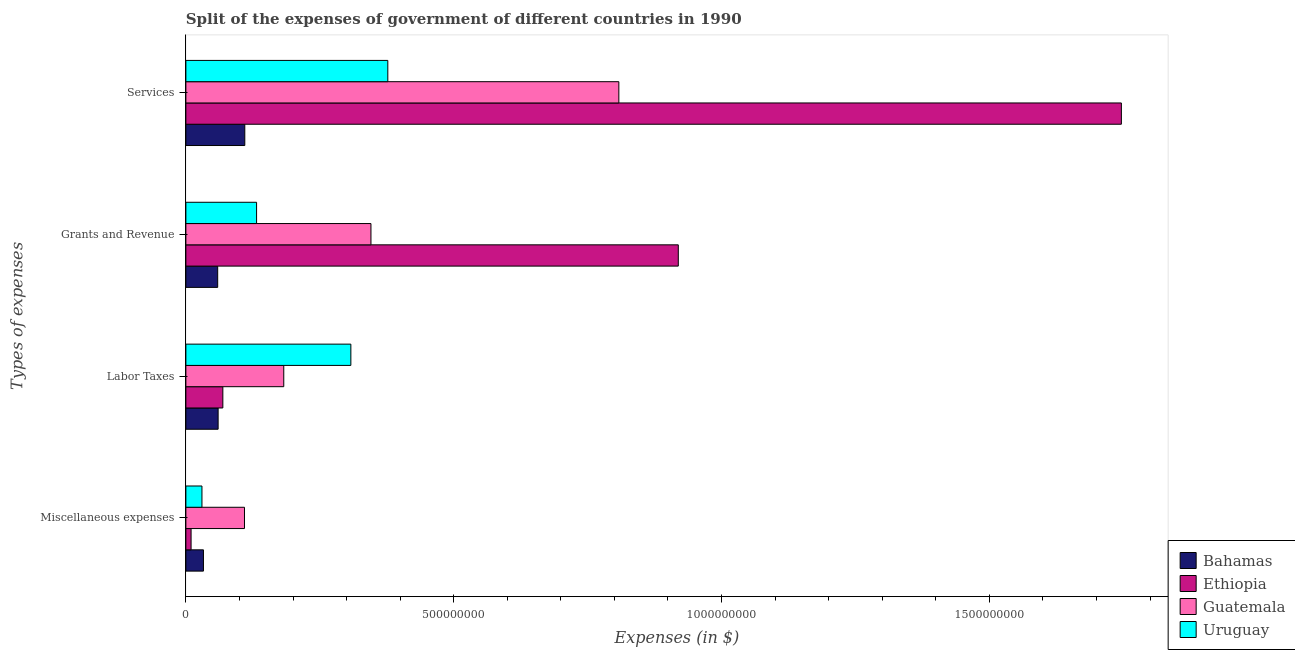How many different coloured bars are there?
Your answer should be very brief. 4. Are the number of bars per tick equal to the number of legend labels?
Provide a succinct answer. Yes. Are the number of bars on each tick of the Y-axis equal?
Your response must be concise. Yes. What is the label of the 2nd group of bars from the top?
Provide a short and direct response. Grants and Revenue. What is the amount spent on grants and revenue in Guatemala?
Make the answer very short. 3.46e+08. Across all countries, what is the maximum amount spent on services?
Ensure brevity in your answer.  1.75e+09. Across all countries, what is the minimum amount spent on grants and revenue?
Ensure brevity in your answer.  5.94e+07. In which country was the amount spent on miscellaneous expenses maximum?
Provide a short and direct response. Guatemala. In which country was the amount spent on services minimum?
Your response must be concise. Bahamas. What is the total amount spent on grants and revenue in the graph?
Provide a short and direct response. 1.46e+09. What is the difference between the amount spent on labor taxes in Bahamas and that in Ethiopia?
Make the answer very short. -8.80e+06. What is the difference between the amount spent on labor taxes in Bahamas and the amount spent on services in Guatemala?
Provide a short and direct response. -7.48e+08. What is the average amount spent on grants and revenue per country?
Your answer should be compact. 3.64e+08. What is the difference between the amount spent on miscellaneous expenses and amount spent on services in Ethiopia?
Ensure brevity in your answer.  -1.74e+09. In how many countries, is the amount spent on grants and revenue greater than 300000000 $?
Your answer should be compact. 2. What is the ratio of the amount spent on services in Uruguay to that in Guatemala?
Your response must be concise. 0.47. What is the difference between the highest and the second highest amount spent on grants and revenue?
Ensure brevity in your answer.  5.74e+08. What is the difference between the highest and the lowest amount spent on grants and revenue?
Ensure brevity in your answer.  8.60e+08. In how many countries, is the amount spent on labor taxes greater than the average amount spent on labor taxes taken over all countries?
Give a very brief answer. 2. Is it the case that in every country, the sum of the amount spent on services and amount spent on grants and revenue is greater than the sum of amount spent on miscellaneous expenses and amount spent on labor taxes?
Make the answer very short. Yes. What does the 1st bar from the top in Miscellaneous expenses represents?
Offer a very short reply. Uruguay. What does the 1st bar from the bottom in Miscellaneous expenses represents?
Your answer should be compact. Bahamas. How many bars are there?
Your answer should be compact. 16. Are all the bars in the graph horizontal?
Give a very brief answer. Yes. Does the graph contain any zero values?
Make the answer very short. No. Does the graph contain grids?
Ensure brevity in your answer.  No. Where does the legend appear in the graph?
Your answer should be very brief. Bottom right. What is the title of the graph?
Offer a very short reply. Split of the expenses of government of different countries in 1990. Does "Haiti" appear as one of the legend labels in the graph?
Your answer should be compact. No. What is the label or title of the X-axis?
Offer a terse response. Expenses (in $). What is the label or title of the Y-axis?
Provide a succinct answer. Types of expenses. What is the Expenses (in $) of Bahamas in Miscellaneous expenses?
Ensure brevity in your answer.  3.28e+07. What is the Expenses (in $) in Ethiopia in Miscellaneous expenses?
Your answer should be compact. 9.70e+06. What is the Expenses (in $) in Guatemala in Miscellaneous expenses?
Offer a very short reply. 1.09e+08. What is the Expenses (in $) of Uruguay in Miscellaneous expenses?
Give a very brief answer. 3.00e+07. What is the Expenses (in $) of Bahamas in Labor Taxes?
Provide a succinct answer. 6.02e+07. What is the Expenses (in $) in Ethiopia in Labor Taxes?
Provide a short and direct response. 6.90e+07. What is the Expenses (in $) in Guatemala in Labor Taxes?
Your answer should be compact. 1.83e+08. What is the Expenses (in $) of Uruguay in Labor Taxes?
Ensure brevity in your answer.  3.08e+08. What is the Expenses (in $) in Bahamas in Grants and Revenue?
Offer a terse response. 5.94e+07. What is the Expenses (in $) of Ethiopia in Grants and Revenue?
Ensure brevity in your answer.  9.19e+08. What is the Expenses (in $) of Guatemala in Grants and Revenue?
Keep it short and to the point. 3.46e+08. What is the Expenses (in $) of Uruguay in Grants and Revenue?
Keep it short and to the point. 1.32e+08. What is the Expenses (in $) of Bahamas in Services?
Your response must be concise. 1.10e+08. What is the Expenses (in $) in Ethiopia in Services?
Offer a very short reply. 1.75e+09. What is the Expenses (in $) in Guatemala in Services?
Your response must be concise. 8.08e+08. What is the Expenses (in $) of Uruguay in Services?
Provide a succinct answer. 3.77e+08. Across all Types of expenses, what is the maximum Expenses (in $) in Bahamas?
Provide a succinct answer. 1.10e+08. Across all Types of expenses, what is the maximum Expenses (in $) of Ethiopia?
Offer a terse response. 1.75e+09. Across all Types of expenses, what is the maximum Expenses (in $) in Guatemala?
Your answer should be very brief. 8.08e+08. Across all Types of expenses, what is the maximum Expenses (in $) in Uruguay?
Make the answer very short. 3.77e+08. Across all Types of expenses, what is the minimum Expenses (in $) in Bahamas?
Offer a terse response. 3.28e+07. Across all Types of expenses, what is the minimum Expenses (in $) of Ethiopia?
Provide a short and direct response. 9.70e+06. Across all Types of expenses, what is the minimum Expenses (in $) of Guatemala?
Keep it short and to the point. 1.09e+08. Across all Types of expenses, what is the minimum Expenses (in $) of Uruguay?
Keep it short and to the point. 3.00e+07. What is the total Expenses (in $) in Bahamas in the graph?
Your response must be concise. 2.62e+08. What is the total Expenses (in $) in Ethiopia in the graph?
Make the answer very short. 2.74e+09. What is the total Expenses (in $) in Guatemala in the graph?
Ensure brevity in your answer.  1.45e+09. What is the total Expenses (in $) of Uruguay in the graph?
Provide a succinct answer. 8.47e+08. What is the difference between the Expenses (in $) in Bahamas in Miscellaneous expenses and that in Labor Taxes?
Your answer should be very brief. -2.74e+07. What is the difference between the Expenses (in $) of Ethiopia in Miscellaneous expenses and that in Labor Taxes?
Your answer should be very brief. -5.93e+07. What is the difference between the Expenses (in $) in Guatemala in Miscellaneous expenses and that in Labor Taxes?
Offer a very short reply. -7.33e+07. What is the difference between the Expenses (in $) of Uruguay in Miscellaneous expenses and that in Labor Taxes?
Offer a terse response. -2.78e+08. What is the difference between the Expenses (in $) of Bahamas in Miscellaneous expenses and that in Grants and Revenue?
Provide a succinct answer. -2.66e+07. What is the difference between the Expenses (in $) in Ethiopia in Miscellaneous expenses and that in Grants and Revenue?
Provide a short and direct response. -9.10e+08. What is the difference between the Expenses (in $) in Guatemala in Miscellaneous expenses and that in Grants and Revenue?
Offer a terse response. -2.36e+08. What is the difference between the Expenses (in $) in Uruguay in Miscellaneous expenses and that in Grants and Revenue?
Offer a very short reply. -1.02e+08. What is the difference between the Expenses (in $) in Bahamas in Miscellaneous expenses and that in Services?
Offer a terse response. -7.72e+07. What is the difference between the Expenses (in $) of Ethiopia in Miscellaneous expenses and that in Services?
Provide a short and direct response. -1.74e+09. What is the difference between the Expenses (in $) of Guatemala in Miscellaneous expenses and that in Services?
Make the answer very short. -6.99e+08. What is the difference between the Expenses (in $) of Uruguay in Miscellaneous expenses and that in Services?
Your answer should be very brief. -3.47e+08. What is the difference between the Expenses (in $) in Ethiopia in Labor Taxes and that in Grants and Revenue?
Offer a very short reply. -8.50e+08. What is the difference between the Expenses (in $) of Guatemala in Labor Taxes and that in Grants and Revenue?
Your answer should be compact. -1.63e+08. What is the difference between the Expenses (in $) in Uruguay in Labor Taxes and that in Grants and Revenue?
Your answer should be compact. 1.76e+08. What is the difference between the Expenses (in $) of Bahamas in Labor Taxes and that in Services?
Provide a succinct answer. -4.98e+07. What is the difference between the Expenses (in $) of Ethiopia in Labor Taxes and that in Services?
Offer a terse response. -1.68e+09. What is the difference between the Expenses (in $) in Guatemala in Labor Taxes and that in Services?
Your answer should be compact. -6.26e+08. What is the difference between the Expenses (in $) of Uruguay in Labor Taxes and that in Services?
Provide a succinct answer. -6.90e+07. What is the difference between the Expenses (in $) in Bahamas in Grants and Revenue and that in Services?
Offer a very short reply. -5.06e+07. What is the difference between the Expenses (in $) of Ethiopia in Grants and Revenue and that in Services?
Ensure brevity in your answer.  -8.27e+08. What is the difference between the Expenses (in $) in Guatemala in Grants and Revenue and that in Services?
Provide a succinct answer. -4.63e+08. What is the difference between the Expenses (in $) of Uruguay in Grants and Revenue and that in Services?
Offer a terse response. -2.45e+08. What is the difference between the Expenses (in $) in Bahamas in Miscellaneous expenses and the Expenses (in $) in Ethiopia in Labor Taxes?
Offer a very short reply. -3.62e+07. What is the difference between the Expenses (in $) of Bahamas in Miscellaneous expenses and the Expenses (in $) of Guatemala in Labor Taxes?
Your response must be concise. -1.50e+08. What is the difference between the Expenses (in $) in Bahamas in Miscellaneous expenses and the Expenses (in $) in Uruguay in Labor Taxes?
Make the answer very short. -2.75e+08. What is the difference between the Expenses (in $) of Ethiopia in Miscellaneous expenses and the Expenses (in $) of Guatemala in Labor Taxes?
Your answer should be compact. -1.73e+08. What is the difference between the Expenses (in $) of Ethiopia in Miscellaneous expenses and the Expenses (in $) of Uruguay in Labor Taxes?
Provide a succinct answer. -2.98e+08. What is the difference between the Expenses (in $) of Guatemala in Miscellaneous expenses and the Expenses (in $) of Uruguay in Labor Taxes?
Your response must be concise. -1.99e+08. What is the difference between the Expenses (in $) in Bahamas in Miscellaneous expenses and the Expenses (in $) in Ethiopia in Grants and Revenue?
Make the answer very short. -8.86e+08. What is the difference between the Expenses (in $) of Bahamas in Miscellaneous expenses and the Expenses (in $) of Guatemala in Grants and Revenue?
Offer a terse response. -3.13e+08. What is the difference between the Expenses (in $) in Bahamas in Miscellaneous expenses and the Expenses (in $) in Uruguay in Grants and Revenue?
Provide a short and direct response. -9.92e+07. What is the difference between the Expenses (in $) of Ethiopia in Miscellaneous expenses and the Expenses (in $) of Guatemala in Grants and Revenue?
Keep it short and to the point. -3.36e+08. What is the difference between the Expenses (in $) in Ethiopia in Miscellaneous expenses and the Expenses (in $) in Uruguay in Grants and Revenue?
Your response must be concise. -1.22e+08. What is the difference between the Expenses (in $) of Guatemala in Miscellaneous expenses and the Expenses (in $) of Uruguay in Grants and Revenue?
Your answer should be very brief. -2.26e+07. What is the difference between the Expenses (in $) in Bahamas in Miscellaneous expenses and the Expenses (in $) in Ethiopia in Services?
Ensure brevity in your answer.  -1.71e+09. What is the difference between the Expenses (in $) in Bahamas in Miscellaneous expenses and the Expenses (in $) in Guatemala in Services?
Offer a very short reply. -7.76e+08. What is the difference between the Expenses (in $) in Bahamas in Miscellaneous expenses and the Expenses (in $) in Uruguay in Services?
Your answer should be very brief. -3.44e+08. What is the difference between the Expenses (in $) of Ethiopia in Miscellaneous expenses and the Expenses (in $) of Guatemala in Services?
Keep it short and to the point. -7.99e+08. What is the difference between the Expenses (in $) of Ethiopia in Miscellaneous expenses and the Expenses (in $) of Uruguay in Services?
Keep it short and to the point. -3.67e+08. What is the difference between the Expenses (in $) of Guatemala in Miscellaneous expenses and the Expenses (in $) of Uruguay in Services?
Provide a short and direct response. -2.68e+08. What is the difference between the Expenses (in $) in Bahamas in Labor Taxes and the Expenses (in $) in Ethiopia in Grants and Revenue?
Provide a short and direct response. -8.59e+08. What is the difference between the Expenses (in $) of Bahamas in Labor Taxes and the Expenses (in $) of Guatemala in Grants and Revenue?
Your answer should be compact. -2.85e+08. What is the difference between the Expenses (in $) in Bahamas in Labor Taxes and the Expenses (in $) in Uruguay in Grants and Revenue?
Your answer should be compact. -7.18e+07. What is the difference between the Expenses (in $) of Ethiopia in Labor Taxes and the Expenses (in $) of Guatemala in Grants and Revenue?
Provide a succinct answer. -2.77e+08. What is the difference between the Expenses (in $) in Ethiopia in Labor Taxes and the Expenses (in $) in Uruguay in Grants and Revenue?
Ensure brevity in your answer.  -6.30e+07. What is the difference between the Expenses (in $) in Guatemala in Labor Taxes and the Expenses (in $) in Uruguay in Grants and Revenue?
Your answer should be very brief. 5.07e+07. What is the difference between the Expenses (in $) of Bahamas in Labor Taxes and the Expenses (in $) of Ethiopia in Services?
Your answer should be compact. -1.69e+09. What is the difference between the Expenses (in $) in Bahamas in Labor Taxes and the Expenses (in $) in Guatemala in Services?
Offer a terse response. -7.48e+08. What is the difference between the Expenses (in $) of Bahamas in Labor Taxes and the Expenses (in $) of Uruguay in Services?
Provide a succinct answer. -3.17e+08. What is the difference between the Expenses (in $) of Ethiopia in Labor Taxes and the Expenses (in $) of Guatemala in Services?
Ensure brevity in your answer.  -7.39e+08. What is the difference between the Expenses (in $) of Ethiopia in Labor Taxes and the Expenses (in $) of Uruguay in Services?
Offer a terse response. -3.08e+08. What is the difference between the Expenses (in $) in Guatemala in Labor Taxes and the Expenses (in $) in Uruguay in Services?
Offer a terse response. -1.94e+08. What is the difference between the Expenses (in $) in Bahamas in Grants and Revenue and the Expenses (in $) in Ethiopia in Services?
Ensure brevity in your answer.  -1.69e+09. What is the difference between the Expenses (in $) in Bahamas in Grants and Revenue and the Expenses (in $) in Guatemala in Services?
Ensure brevity in your answer.  -7.49e+08. What is the difference between the Expenses (in $) in Bahamas in Grants and Revenue and the Expenses (in $) in Uruguay in Services?
Give a very brief answer. -3.18e+08. What is the difference between the Expenses (in $) of Ethiopia in Grants and Revenue and the Expenses (in $) of Guatemala in Services?
Your response must be concise. 1.11e+08. What is the difference between the Expenses (in $) in Ethiopia in Grants and Revenue and the Expenses (in $) in Uruguay in Services?
Offer a very short reply. 5.42e+08. What is the difference between the Expenses (in $) in Guatemala in Grants and Revenue and the Expenses (in $) in Uruguay in Services?
Keep it short and to the point. -3.15e+07. What is the average Expenses (in $) of Bahamas per Types of expenses?
Ensure brevity in your answer.  6.56e+07. What is the average Expenses (in $) of Ethiopia per Types of expenses?
Your response must be concise. 6.86e+08. What is the average Expenses (in $) in Guatemala per Types of expenses?
Your answer should be very brief. 3.62e+08. What is the average Expenses (in $) of Uruguay per Types of expenses?
Ensure brevity in your answer.  2.12e+08. What is the difference between the Expenses (in $) in Bahamas and Expenses (in $) in Ethiopia in Miscellaneous expenses?
Your answer should be very brief. 2.31e+07. What is the difference between the Expenses (in $) in Bahamas and Expenses (in $) in Guatemala in Miscellaneous expenses?
Provide a short and direct response. -7.66e+07. What is the difference between the Expenses (in $) in Bahamas and Expenses (in $) in Uruguay in Miscellaneous expenses?
Ensure brevity in your answer.  2.80e+06. What is the difference between the Expenses (in $) in Ethiopia and Expenses (in $) in Guatemala in Miscellaneous expenses?
Ensure brevity in your answer.  -9.97e+07. What is the difference between the Expenses (in $) in Ethiopia and Expenses (in $) in Uruguay in Miscellaneous expenses?
Your answer should be very brief. -2.03e+07. What is the difference between the Expenses (in $) of Guatemala and Expenses (in $) of Uruguay in Miscellaneous expenses?
Your answer should be compact. 7.94e+07. What is the difference between the Expenses (in $) in Bahamas and Expenses (in $) in Ethiopia in Labor Taxes?
Your answer should be very brief. -8.80e+06. What is the difference between the Expenses (in $) of Bahamas and Expenses (in $) of Guatemala in Labor Taxes?
Your answer should be very brief. -1.23e+08. What is the difference between the Expenses (in $) of Bahamas and Expenses (in $) of Uruguay in Labor Taxes?
Give a very brief answer. -2.48e+08. What is the difference between the Expenses (in $) in Ethiopia and Expenses (in $) in Guatemala in Labor Taxes?
Your response must be concise. -1.14e+08. What is the difference between the Expenses (in $) of Ethiopia and Expenses (in $) of Uruguay in Labor Taxes?
Provide a succinct answer. -2.39e+08. What is the difference between the Expenses (in $) in Guatemala and Expenses (in $) in Uruguay in Labor Taxes?
Your answer should be very brief. -1.25e+08. What is the difference between the Expenses (in $) in Bahamas and Expenses (in $) in Ethiopia in Grants and Revenue?
Offer a terse response. -8.60e+08. What is the difference between the Expenses (in $) in Bahamas and Expenses (in $) in Guatemala in Grants and Revenue?
Provide a short and direct response. -2.86e+08. What is the difference between the Expenses (in $) of Bahamas and Expenses (in $) of Uruguay in Grants and Revenue?
Your answer should be compact. -7.26e+07. What is the difference between the Expenses (in $) in Ethiopia and Expenses (in $) in Guatemala in Grants and Revenue?
Offer a very short reply. 5.74e+08. What is the difference between the Expenses (in $) of Ethiopia and Expenses (in $) of Uruguay in Grants and Revenue?
Offer a terse response. 7.87e+08. What is the difference between the Expenses (in $) of Guatemala and Expenses (in $) of Uruguay in Grants and Revenue?
Offer a very short reply. 2.14e+08. What is the difference between the Expenses (in $) in Bahamas and Expenses (in $) in Ethiopia in Services?
Ensure brevity in your answer.  -1.64e+09. What is the difference between the Expenses (in $) of Bahamas and Expenses (in $) of Guatemala in Services?
Your answer should be compact. -6.98e+08. What is the difference between the Expenses (in $) in Bahamas and Expenses (in $) in Uruguay in Services?
Offer a very short reply. -2.67e+08. What is the difference between the Expenses (in $) in Ethiopia and Expenses (in $) in Guatemala in Services?
Make the answer very short. 9.38e+08. What is the difference between the Expenses (in $) in Ethiopia and Expenses (in $) in Uruguay in Services?
Your response must be concise. 1.37e+09. What is the difference between the Expenses (in $) in Guatemala and Expenses (in $) in Uruguay in Services?
Make the answer very short. 4.31e+08. What is the ratio of the Expenses (in $) in Bahamas in Miscellaneous expenses to that in Labor Taxes?
Offer a terse response. 0.54. What is the ratio of the Expenses (in $) in Ethiopia in Miscellaneous expenses to that in Labor Taxes?
Your response must be concise. 0.14. What is the ratio of the Expenses (in $) of Guatemala in Miscellaneous expenses to that in Labor Taxes?
Ensure brevity in your answer.  0.6. What is the ratio of the Expenses (in $) of Uruguay in Miscellaneous expenses to that in Labor Taxes?
Ensure brevity in your answer.  0.1. What is the ratio of the Expenses (in $) of Bahamas in Miscellaneous expenses to that in Grants and Revenue?
Keep it short and to the point. 0.55. What is the ratio of the Expenses (in $) in Ethiopia in Miscellaneous expenses to that in Grants and Revenue?
Your response must be concise. 0.01. What is the ratio of the Expenses (in $) in Guatemala in Miscellaneous expenses to that in Grants and Revenue?
Ensure brevity in your answer.  0.32. What is the ratio of the Expenses (in $) of Uruguay in Miscellaneous expenses to that in Grants and Revenue?
Your answer should be very brief. 0.23. What is the ratio of the Expenses (in $) in Bahamas in Miscellaneous expenses to that in Services?
Provide a succinct answer. 0.3. What is the ratio of the Expenses (in $) in Ethiopia in Miscellaneous expenses to that in Services?
Provide a succinct answer. 0.01. What is the ratio of the Expenses (in $) in Guatemala in Miscellaneous expenses to that in Services?
Your answer should be compact. 0.14. What is the ratio of the Expenses (in $) of Uruguay in Miscellaneous expenses to that in Services?
Offer a very short reply. 0.08. What is the ratio of the Expenses (in $) in Bahamas in Labor Taxes to that in Grants and Revenue?
Ensure brevity in your answer.  1.01. What is the ratio of the Expenses (in $) of Ethiopia in Labor Taxes to that in Grants and Revenue?
Give a very brief answer. 0.08. What is the ratio of the Expenses (in $) of Guatemala in Labor Taxes to that in Grants and Revenue?
Make the answer very short. 0.53. What is the ratio of the Expenses (in $) of Uruguay in Labor Taxes to that in Grants and Revenue?
Provide a short and direct response. 2.33. What is the ratio of the Expenses (in $) in Bahamas in Labor Taxes to that in Services?
Your answer should be compact. 0.55. What is the ratio of the Expenses (in $) in Ethiopia in Labor Taxes to that in Services?
Ensure brevity in your answer.  0.04. What is the ratio of the Expenses (in $) of Guatemala in Labor Taxes to that in Services?
Your answer should be compact. 0.23. What is the ratio of the Expenses (in $) of Uruguay in Labor Taxes to that in Services?
Make the answer very short. 0.82. What is the ratio of the Expenses (in $) in Bahamas in Grants and Revenue to that in Services?
Provide a short and direct response. 0.54. What is the ratio of the Expenses (in $) of Ethiopia in Grants and Revenue to that in Services?
Give a very brief answer. 0.53. What is the ratio of the Expenses (in $) in Guatemala in Grants and Revenue to that in Services?
Make the answer very short. 0.43. What is the ratio of the Expenses (in $) of Uruguay in Grants and Revenue to that in Services?
Provide a short and direct response. 0.35. What is the difference between the highest and the second highest Expenses (in $) of Bahamas?
Your response must be concise. 4.98e+07. What is the difference between the highest and the second highest Expenses (in $) of Ethiopia?
Your answer should be very brief. 8.27e+08. What is the difference between the highest and the second highest Expenses (in $) of Guatemala?
Offer a terse response. 4.63e+08. What is the difference between the highest and the second highest Expenses (in $) in Uruguay?
Offer a very short reply. 6.90e+07. What is the difference between the highest and the lowest Expenses (in $) of Bahamas?
Provide a succinct answer. 7.72e+07. What is the difference between the highest and the lowest Expenses (in $) of Ethiopia?
Offer a very short reply. 1.74e+09. What is the difference between the highest and the lowest Expenses (in $) of Guatemala?
Offer a terse response. 6.99e+08. What is the difference between the highest and the lowest Expenses (in $) of Uruguay?
Provide a short and direct response. 3.47e+08. 